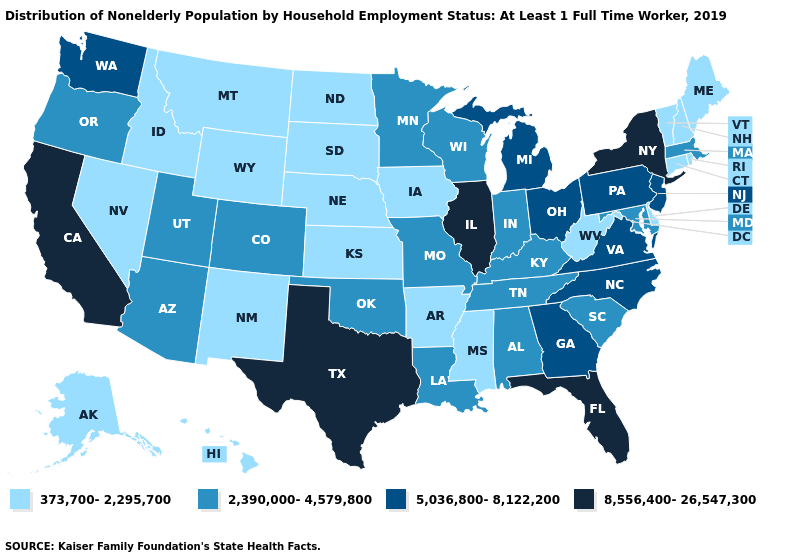Which states have the lowest value in the USA?
Answer briefly. Alaska, Arkansas, Connecticut, Delaware, Hawaii, Idaho, Iowa, Kansas, Maine, Mississippi, Montana, Nebraska, Nevada, New Hampshire, New Mexico, North Dakota, Rhode Island, South Dakota, Vermont, West Virginia, Wyoming. Does Montana have a higher value than Kansas?
Keep it brief. No. Does Minnesota have the lowest value in the USA?
Short answer required. No. Which states hav the highest value in the Northeast?
Write a very short answer. New York. Name the states that have a value in the range 8,556,400-26,547,300?
Keep it brief. California, Florida, Illinois, New York, Texas. What is the highest value in the USA?
Short answer required. 8,556,400-26,547,300. What is the value of Ohio?
Short answer required. 5,036,800-8,122,200. Does Texas have a higher value than California?
Concise answer only. No. What is the highest value in the West ?
Answer briefly. 8,556,400-26,547,300. What is the value of South Carolina?
Give a very brief answer. 2,390,000-4,579,800. Which states have the lowest value in the South?
Be succinct. Arkansas, Delaware, Mississippi, West Virginia. Which states have the highest value in the USA?
Be succinct. California, Florida, Illinois, New York, Texas. How many symbols are there in the legend?
Write a very short answer. 4. Which states hav the highest value in the Northeast?
Give a very brief answer. New York. What is the lowest value in the USA?
Short answer required. 373,700-2,295,700. 